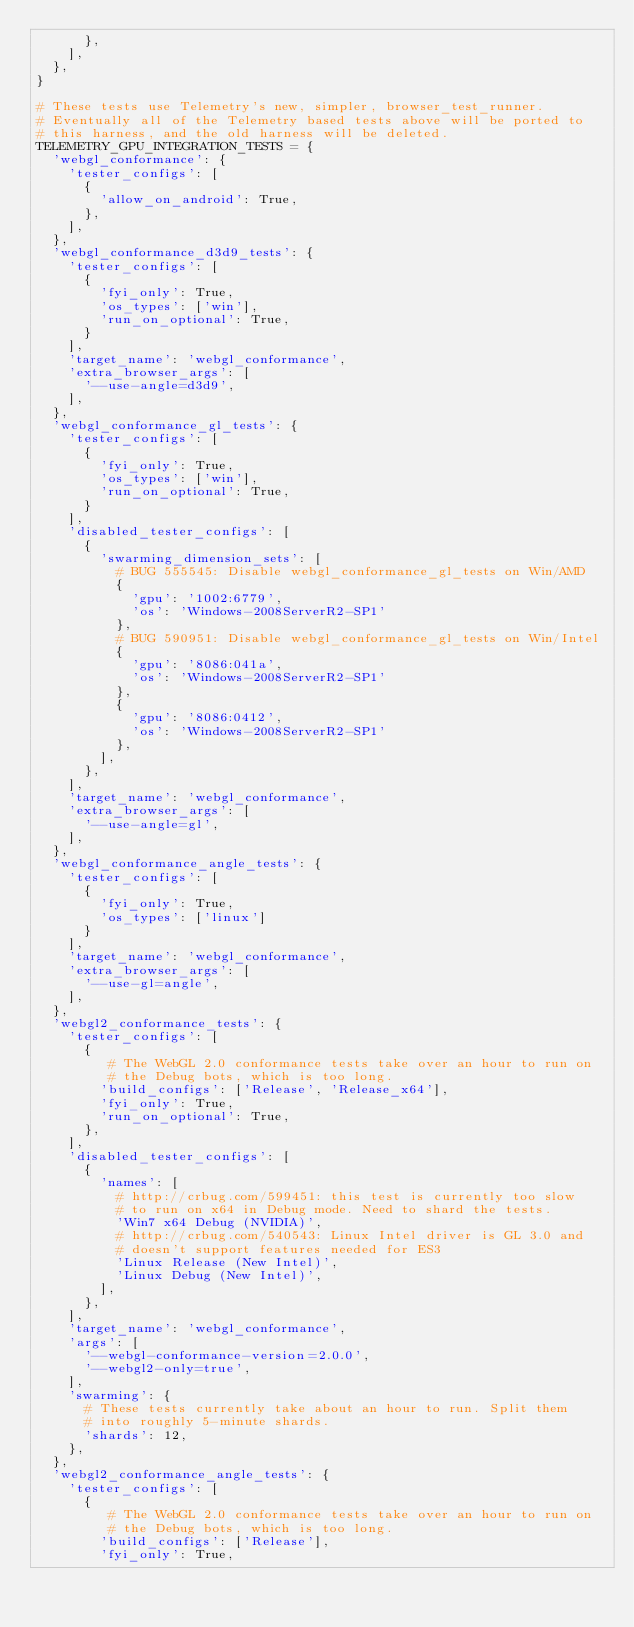Convert code to text. <code><loc_0><loc_0><loc_500><loc_500><_Python_>      },
    ],
  },
}

# These tests use Telemetry's new, simpler, browser_test_runner.
# Eventually all of the Telemetry based tests above will be ported to
# this harness, and the old harness will be deleted.
TELEMETRY_GPU_INTEGRATION_TESTS = {
  'webgl_conformance': {
    'tester_configs': [
      {
        'allow_on_android': True,
      },
    ],
  },
  'webgl_conformance_d3d9_tests': {
    'tester_configs': [
      {
        'fyi_only': True,
        'os_types': ['win'],
        'run_on_optional': True,
      }
    ],
    'target_name': 'webgl_conformance',
    'extra_browser_args': [
      '--use-angle=d3d9',
    ],
  },
  'webgl_conformance_gl_tests': {
    'tester_configs': [
      {
        'fyi_only': True,
        'os_types': ['win'],
        'run_on_optional': True,
      }
    ],
    'disabled_tester_configs': [
      {
        'swarming_dimension_sets': [
          # BUG 555545: Disable webgl_conformance_gl_tests on Win/AMD
          {
            'gpu': '1002:6779',
            'os': 'Windows-2008ServerR2-SP1'
          },
          # BUG 590951: Disable webgl_conformance_gl_tests on Win/Intel
          {
            'gpu': '8086:041a',
            'os': 'Windows-2008ServerR2-SP1'
          },
          {
            'gpu': '8086:0412',
            'os': 'Windows-2008ServerR2-SP1'
          },
        ],
      },
    ],
    'target_name': 'webgl_conformance',
    'extra_browser_args': [
      '--use-angle=gl',
    ],
  },
  'webgl_conformance_angle_tests': {
    'tester_configs': [
      {
        'fyi_only': True,
        'os_types': ['linux']
      }
    ],
    'target_name': 'webgl_conformance',
    'extra_browser_args': [
      '--use-gl=angle',
    ],
  },
  'webgl2_conformance_tests': {
    'tester_configs': [
      {
         # The WebGL 2.0 conformance tests take over an hour to run on
         # the Debug bots, which is too long.
        'build_configs': ['Release', 'Release_x64'],
        'fyi_only': True,
        'run_on_optional': True,
      },
    ],
    'disabled_tester_configs': [
      {
        'names': [
          # http://crbug.com/599451: this test is currently too slow
          # to run on x64 in Debug mode. Need to shard the tests.
          'Win7 x64 Debug (NVIDIA)',
          # http://crbug.com/540543: Linux Intel driver is GL 3.0 and
          # doesn't support features needed for ES3
          'Linux Release (New Intel)',
          'Linux Debug (New Intel)',
        ],
      },
    ],
    'target_name': 'webgl_conformance',
    'args': [
      '--webgl-conformance-version=2.0.0',
      '--webgl2-only=true',
    ],
    'swarming': {
      # These tests currently take about an hour to run. Split them
      # into roughly 5-minute shards.
      'shards': 12,
    },
  },
  'webgl2_conformance_angle_tests': {
    'tester_configs': [
      {
         # The WebGL 2.0 conformance tests take over an hour to run on
         # the Debug bots, which is too long.
        'build_configs': ['Release'],
        'fyi_only': True,</code> 